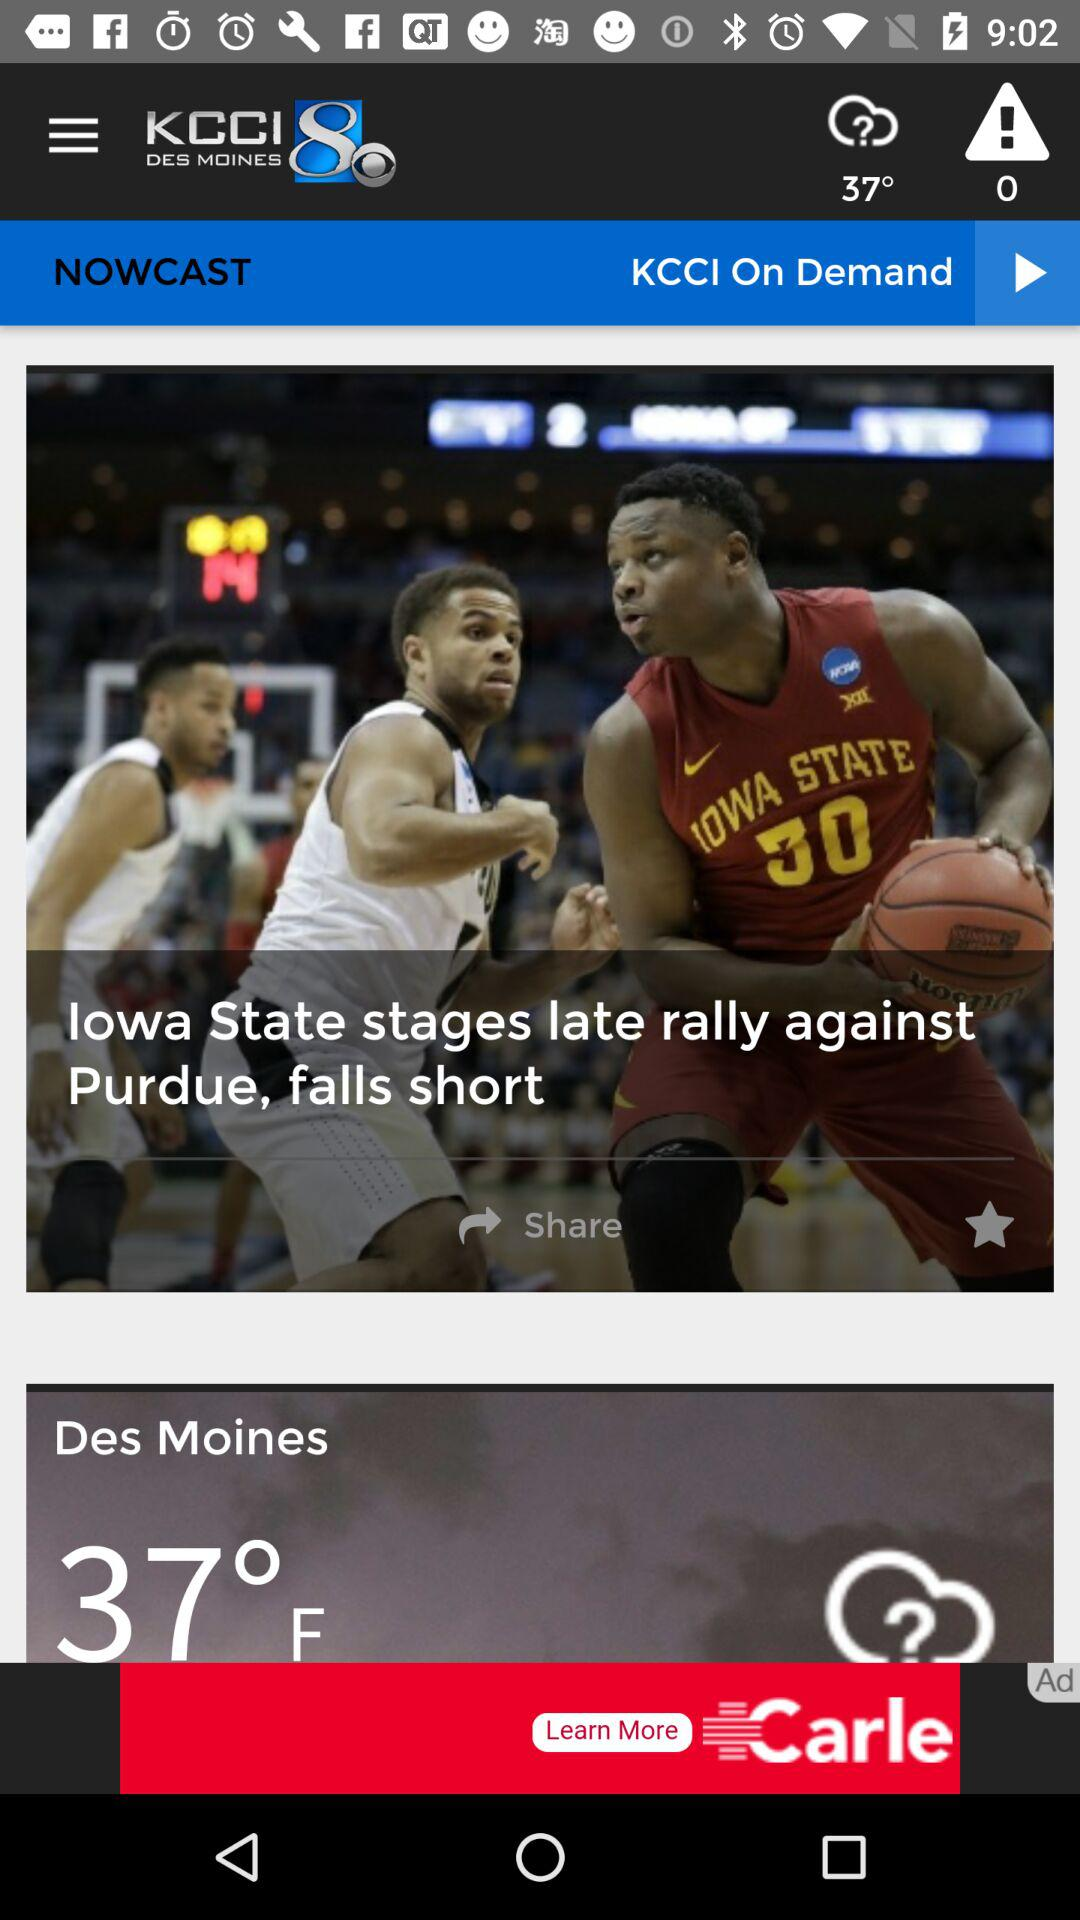How many degrees Fahrenheit is the temperature in Des Moines?
Answer the question using a single word or phrase. 37°F 